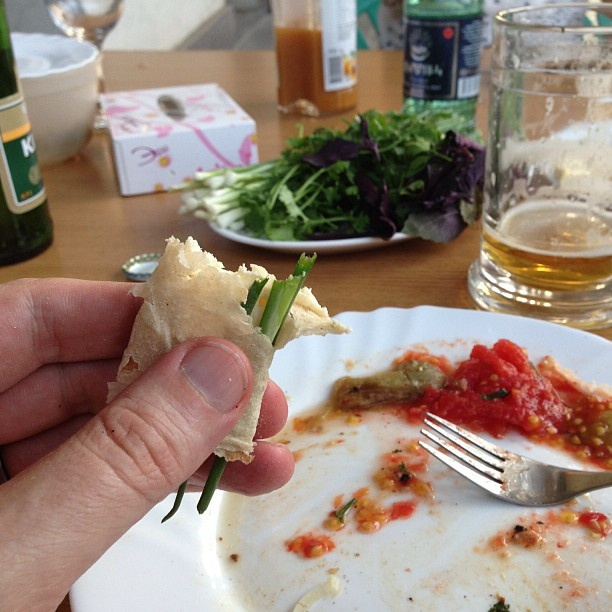Describe the objects in this image and their specific colors. I can see cup in darkgreen, darkgray, tan, gray, and lightgray tones, dining table in darkgreen, gray, maroon, olive, and tan tones, people in darkgreen, gray, darkgray, and lightpink tones, people in darkgreen, maroon, brown, and black tones, and bottle in darkgreen, maroon, darkgray, brown, and lightgray tones in this image. 